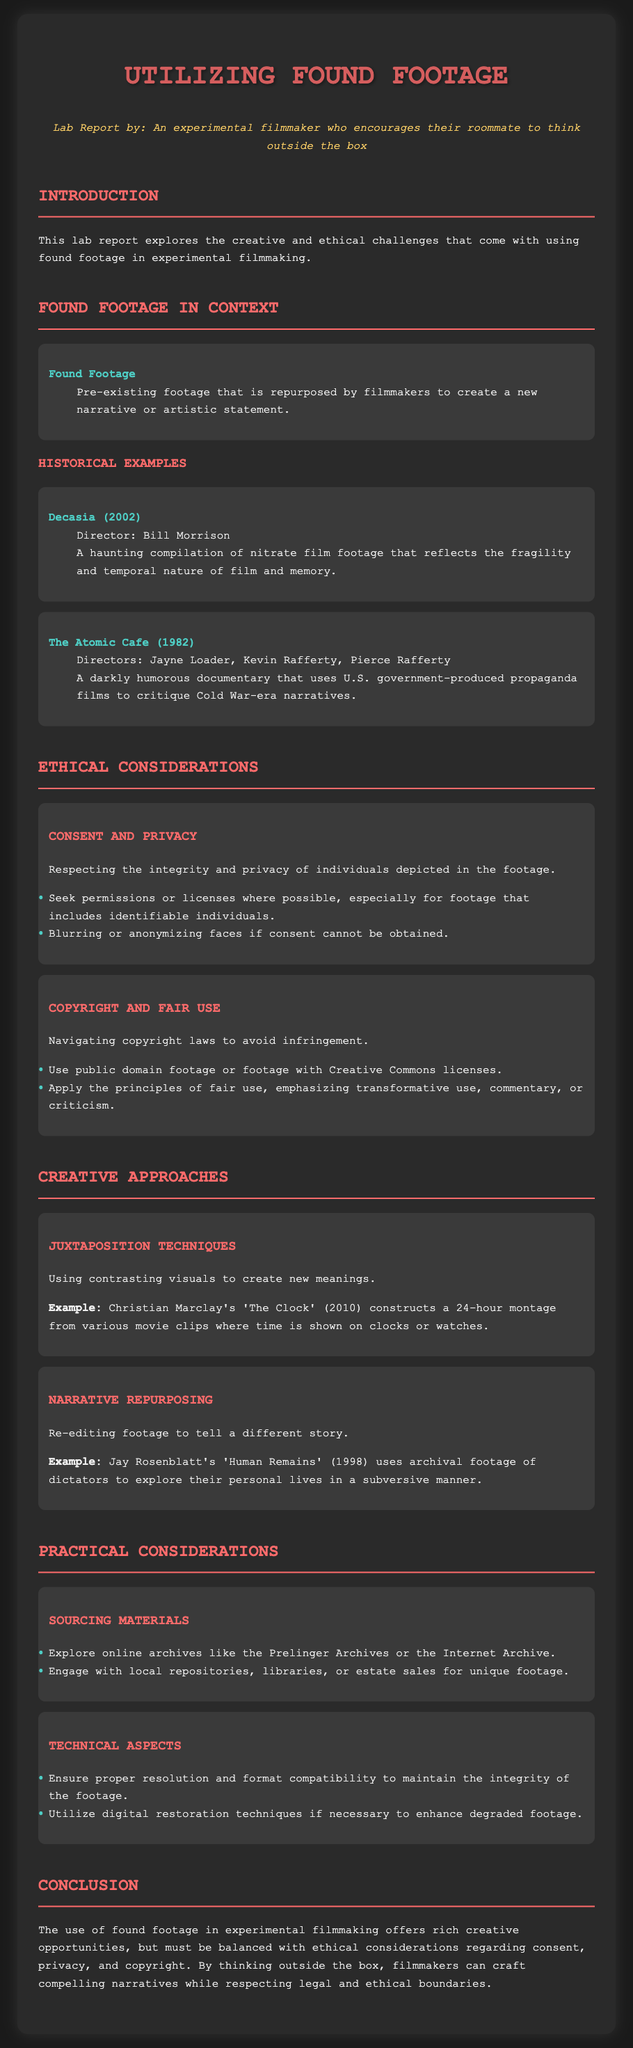What is the title of the lab report? The title is the heading presented at the top of the document.
Answer: Utilizing Found Footage: Lab Report Who directed the film "Decasia"? The director's name is specified in the context of the film described.
Answer: Bill Morrison What year was "The Atomic Cafe" released? The year of release is provided within the historical examples section.
Answer: 1982 What ethical consideration is related to the privacy of individuals in footage? This concern is highlighted under the ethical considerations section of the document.
Answer: Consent and Privacy Which artistic technique is exemplified by Christian Marclay's "The Clock"? The technique mentioned relates to the creative approaches section of the report.
Answer: Juxtaposition Techniques What is suggested for sourcing found footage materials? The document provides specific suggestions under practical considerations.
Answer: Online archives What should filmmakers do if consent cannot be obtained for identifiable individuals? This guideline is offered under ethical considerations regarding consent.
Answer: Blurring or anonymizing faces What year was "Human Remains" released? The release year of this film is listed alongside its description.
Answer: 1998 What is a key aspect of navigating copyright in found footage use? The fundamental element of copyright navigation is indicated in the ethical considerations section.
Answer: Fair Use 